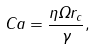Convert formula to latex. <formula><loc_0><loc_0><loc_500><loc_500>C a = \frac { \eta \Omega r _ { c } } { \gamma } ,</formula> 